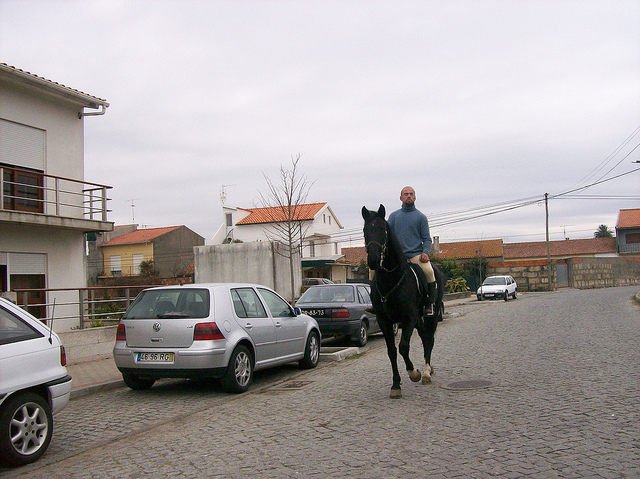<image>What brand are these horses usually associated with? I don't know which brand these horses are usually associated with. It could be 'budweiser'. What brand are these horses usually associated with? It is ambiguous which brand these horses are usually associated with. It can be both racing or Budweiser. 